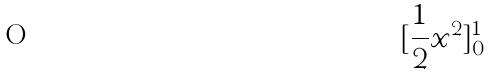<formula> <loc_0><loc_0><loc_500><loc_500>[ \frac { 1 } { 2 } x ^ { 2 } ] _ { 0 } ^ { 1 }</formula> 